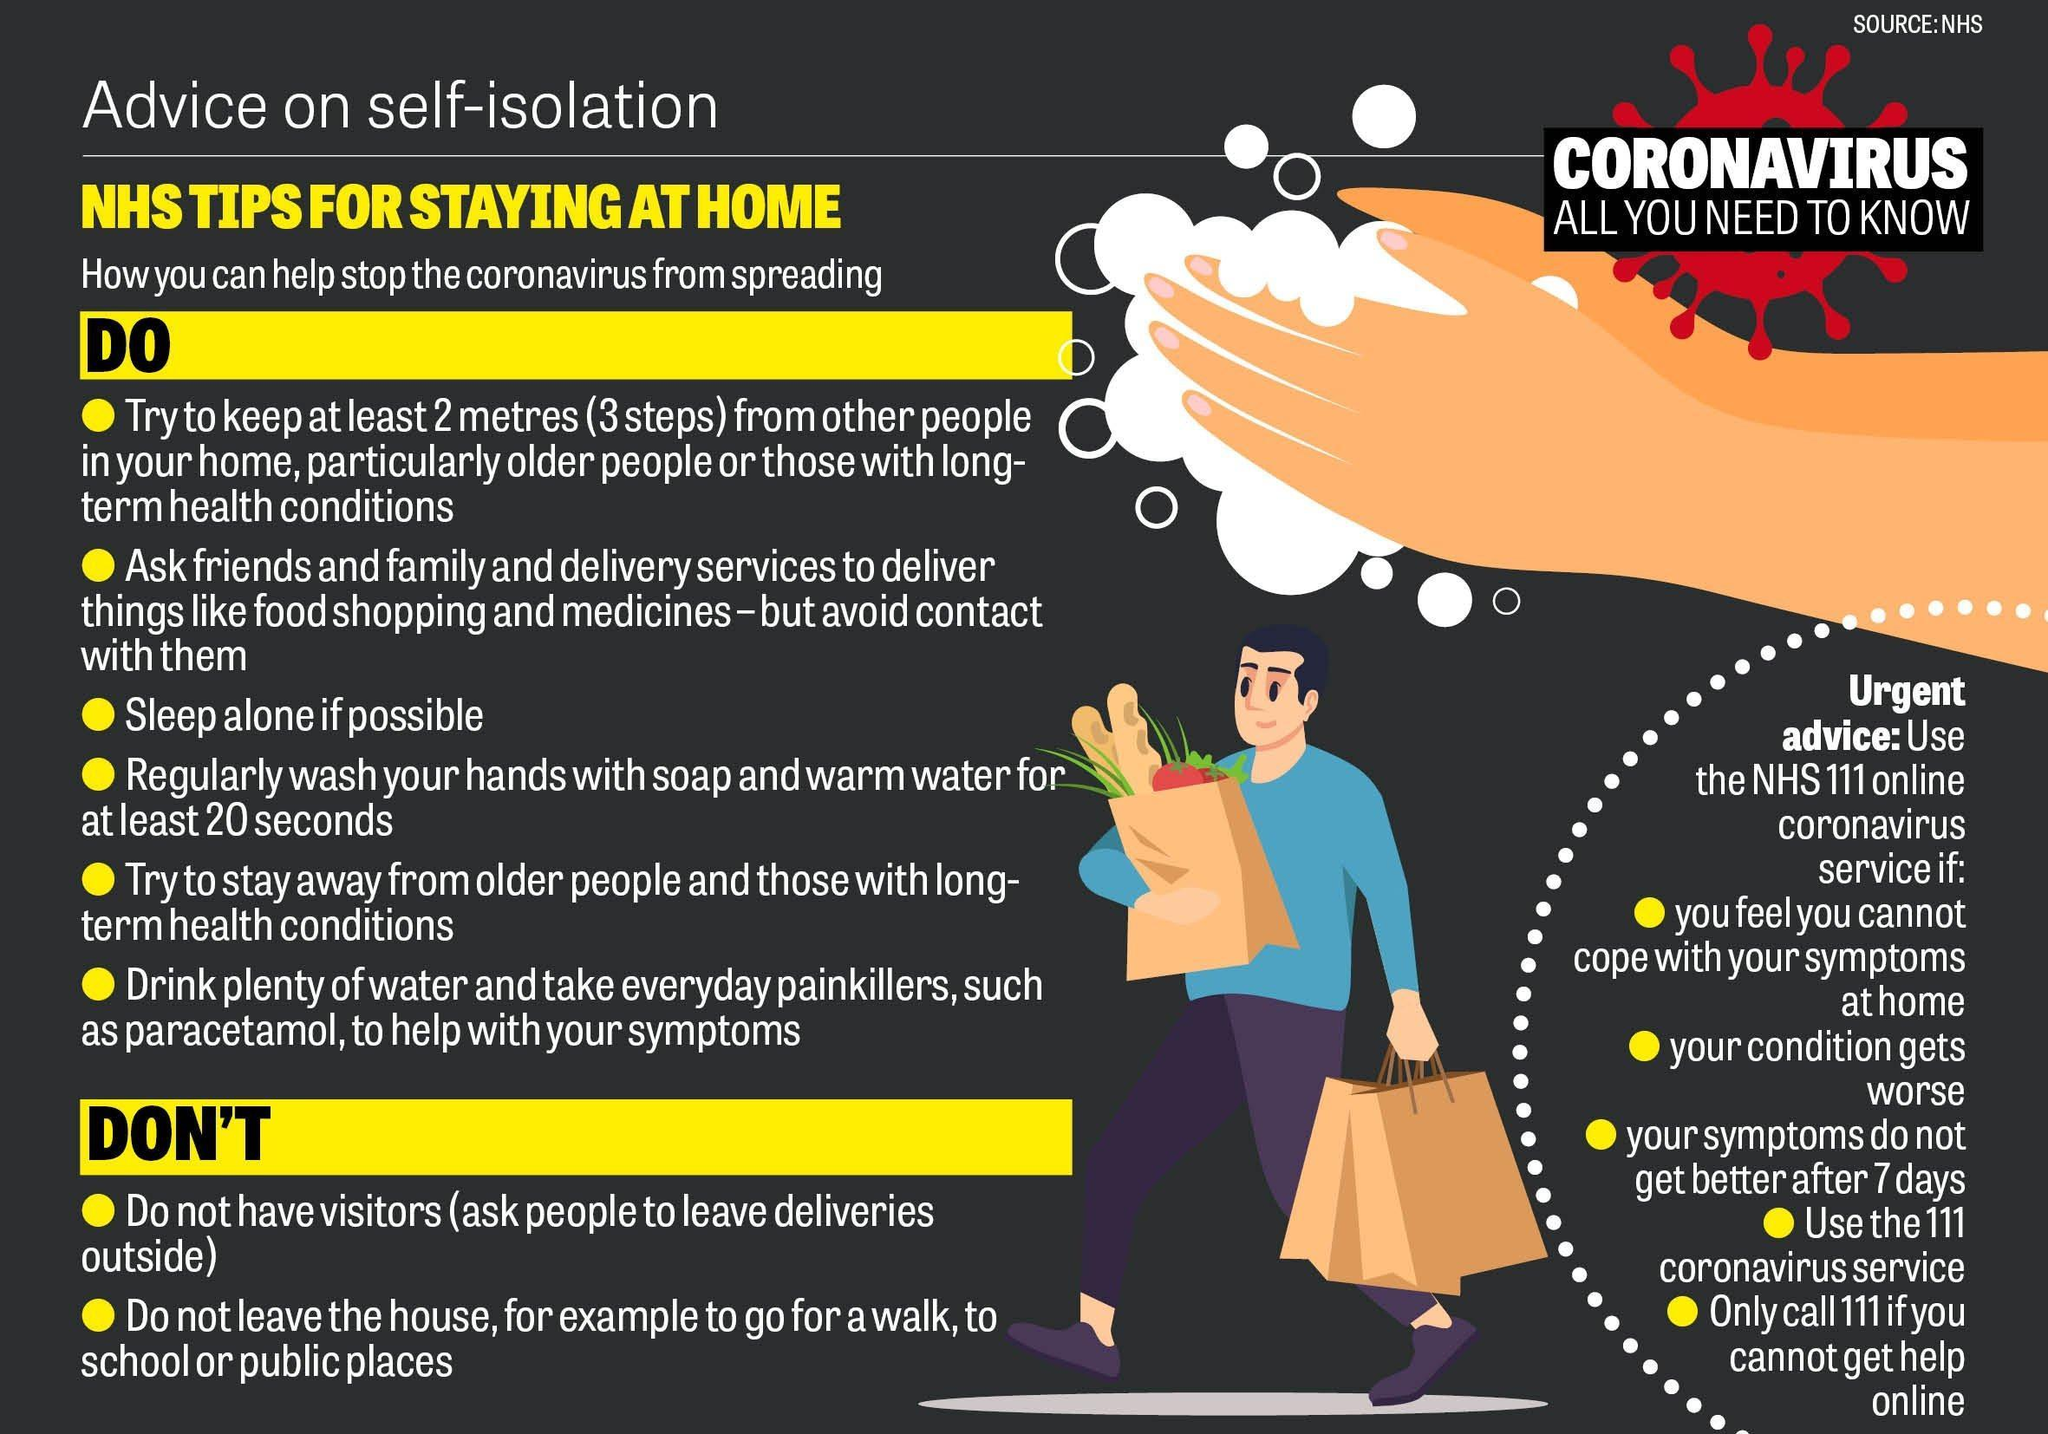Give some essential details in this illustration. If the symptoms do not improve after 7 days, we should use the NHS111 online coronavirus service. It is two points under the 'do not' list, Paracetamol is the painkiller that is mentioned. The number of points under the "Do" list is six. 3 steps are equal to 200 centimetres. 